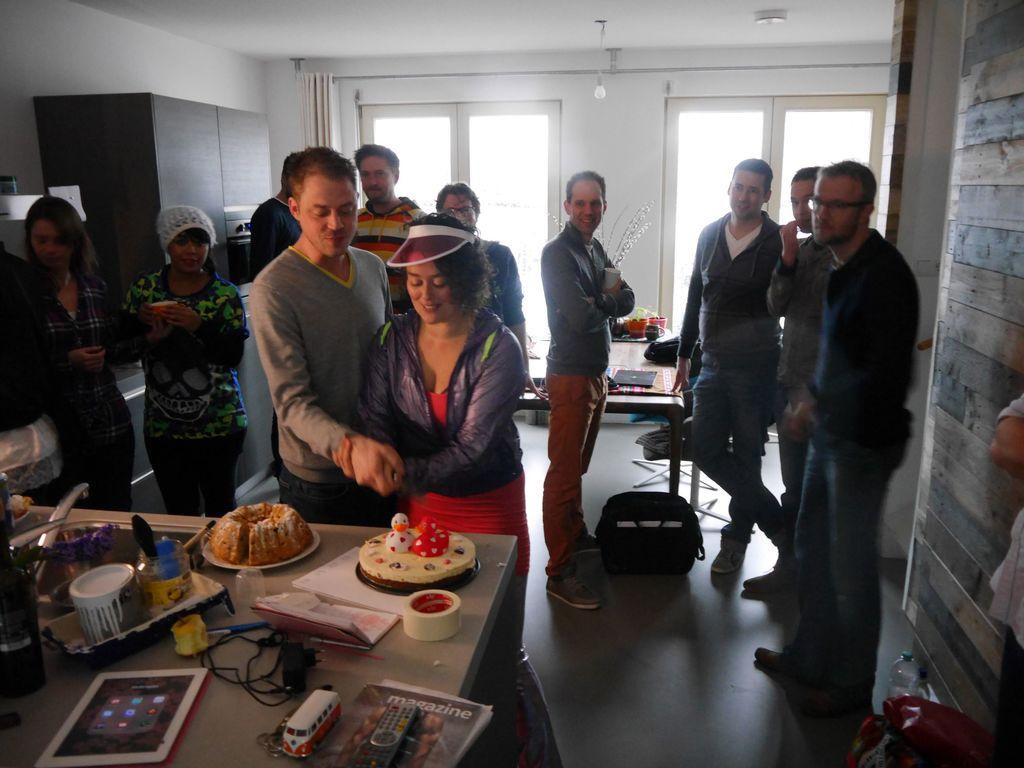How many people are in the image? There is a group of persons in the image. Where are the persons located in the image? The group of persons are standing in a room. Can you describe the activity of the two persons at the foreground of the image? The two persons are cutting a cake. What disease is being discussed by the group of persons in the image? There is no indication in the image that the group of persons is discussing any disease. 